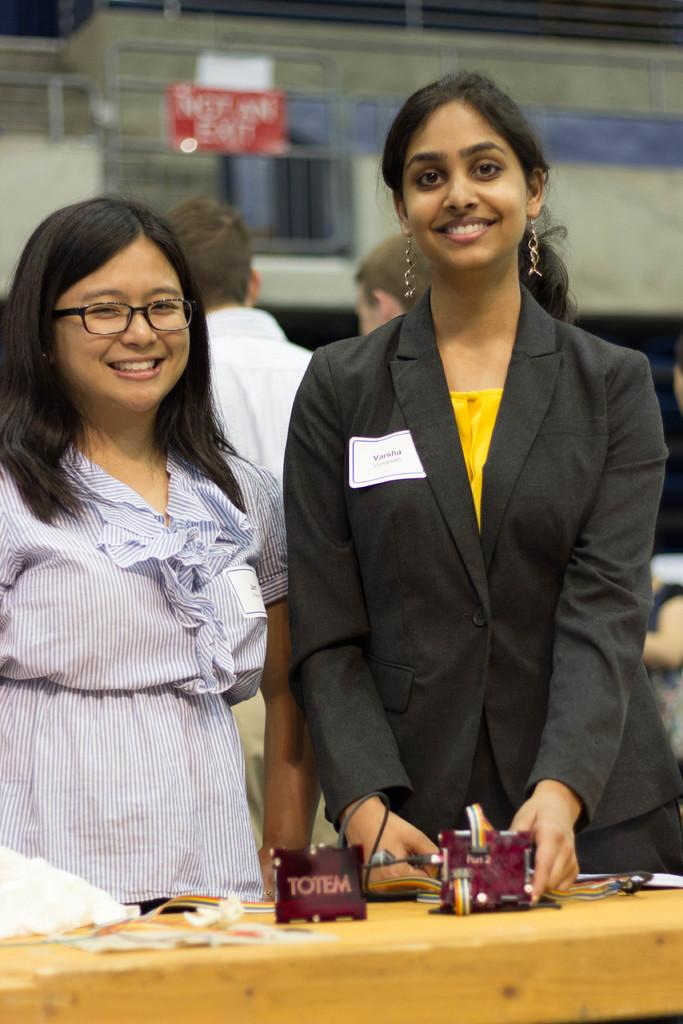How many people are in the image? There are two women in the image. What are the women doing in the image? The women are smiling and being photographed. How many children are present in the image? There are no children present in the image; it features two women. What type of cork is being used to hold the women's hair in the image? There is no cork present in the image, nor is there any indication that the women's hair is being held in place. 